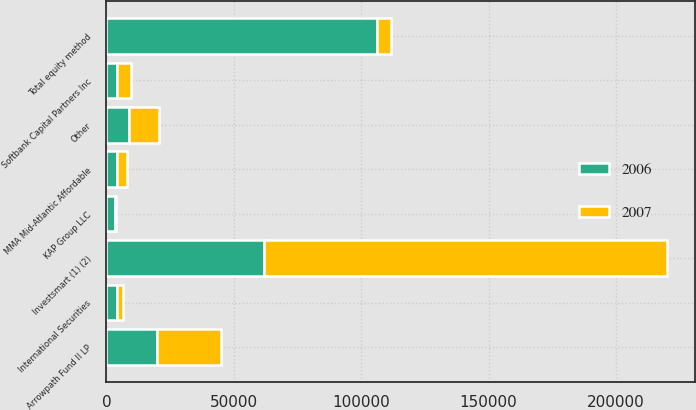<chart> <loc_0><loc_0><loc_500><loc_500><stacked_bar_chart><ecel><fcel>Investsmart (1) (2)<fcel>Arrowpath Fund II LP<fcel>MMA Mid-Atlantic Affordable<fcel>Softbank Capital Partners Inc<fcel>International Securities<fcel>KAP Group LLC<fcel>Other<fcel>Total equity method<nl><fcel>2007<fcel>158236<fcel>25311<fcel>3859<fcel>5520<fcel>2516<fcel>225<fcel>12167<fcel>5520<nl><fcel>2006<fcel>61815<fcel>19861<fcel>4188<fcel>4050<fcel>4000<fcel>3507<fcel>8681<fcel>106102<nl></chart> 